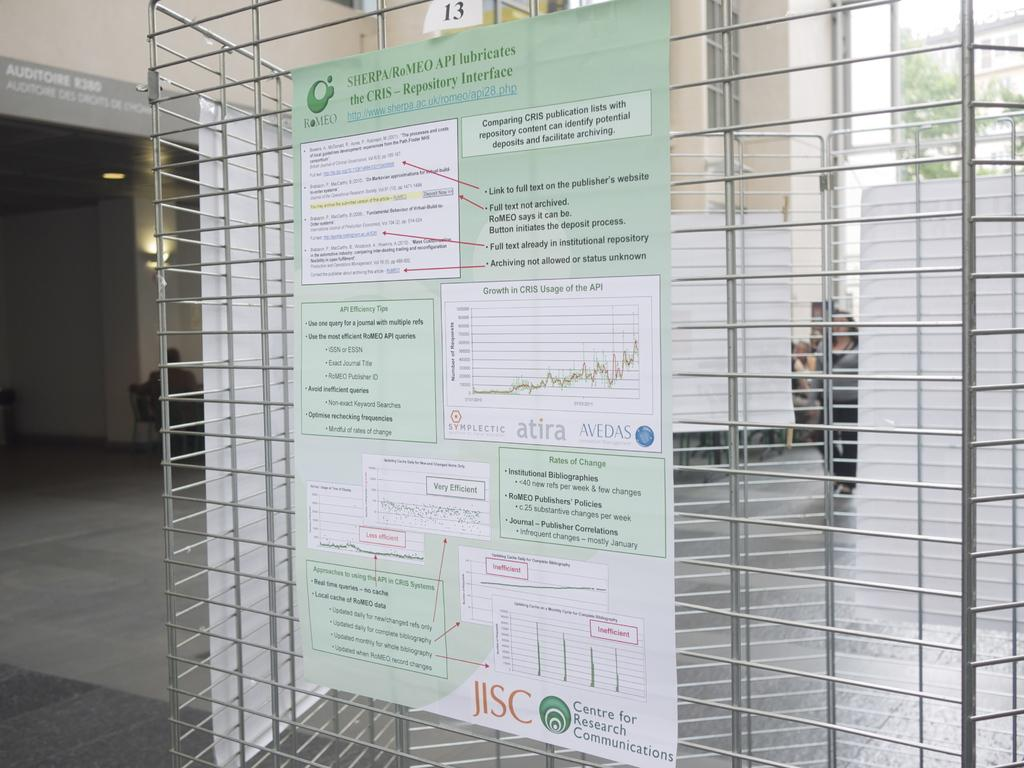<image>
Give a short and clear explanation of the subsequent image. Sign hanging on a fence that says Repository Interface. 